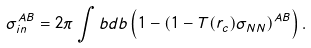<formula> <loc_0><loc_0><loc_500><loc_500>\sigma _ { i n } ^ { A B } = 2 \pi \int b d b \left ( 1 - ( 1 - T ( r _ { c } ) \sigma _ { N N } ) ^ { A B } \right ) .</formula> 